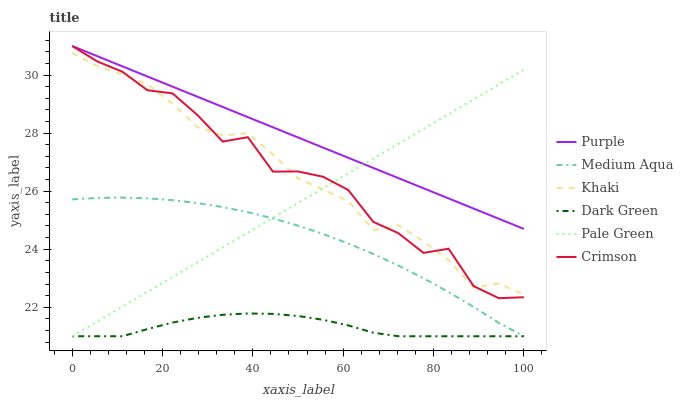Does Dark Green have the minimum area under the curve?
Answer yes or no. Yes. Does Purple have the maximum area under the curve?
Answer yes or no. Yes. Does Pale Green have the minimum area under the curve?
Answer yes or no. No. Does Pale Green have the maximum area under the curve?
Answer yes or no. No. Is Pale Green the smoothest?
Answer yes or no. Yes. Is Crimson the roughest?
Answer yes or no. Yes. Is Purple the smoothest?
Answer yes or no. No. Is Purple the roughest?
Answer yes or no. No. Does Pale Green have the lowest value?
Answer yes or no. Yes. Does Purple have the lowest value?
Answer yes or no. No. Does Crimson have the highest value?
Answer yes or no. Yes. Does Pale Green have the highest value?
Answer yes or no. No. Is Dark Green less than Crimson?
Answer yes or no. Yes. Is Purple greater than Khaki?
Answer yes or no. Yes. Does Crimson intersect Purple?
Answer yes or no. Yes. Is Crimson less than Purple?
Answer yes or no. No. Is Crimson greater than Purple?
Answer yes or no. No. Does Dark Green intersect Crimson?
Answer yes or no. No. 